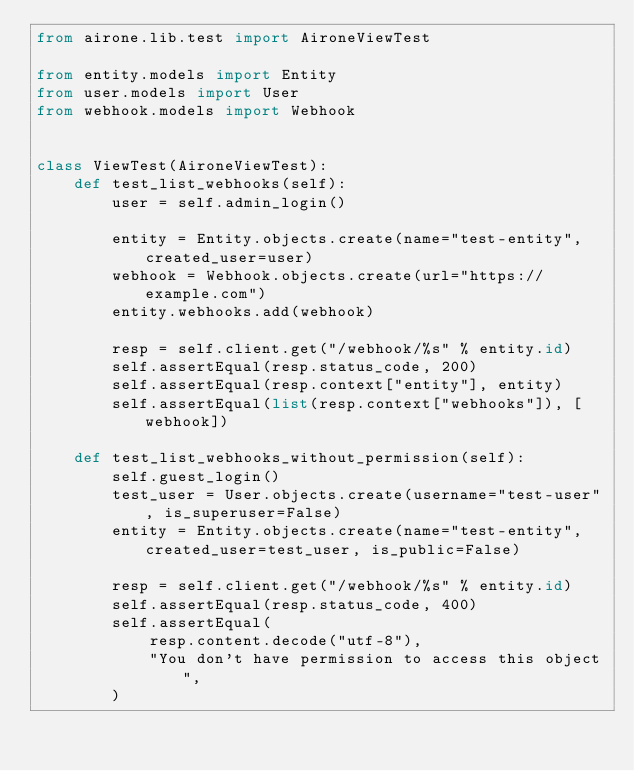Convert code to text. <code><loc_0><loc_0><loc_500><loc_500><_Python_>from airone.lib.test import AironeViewTest

from entity.models import Entity
from user.models import User
from webhook.models import Webhook


class ViewTest(AironeViewTest):
    def test_list_webhooks(self):
        user = self.admin_login()

        entity = Entity.objects.create(name="test-entity", created_user=user)
        webhook = Webhook.objects.create(url="https://example.com")
        entity.webhooks.add(webhook)

        resp = self.client.get("/webhook/%s" % entity.id)
        self.assertEqual(resp.status_code, 200)
        self.assertEqual(resp.context["entity"], entity)
        self.assertEqual(list(resp.context["webhooks"]), [webhook])

    def test_list_webhooks_without_permission(self):
        self.guest_login()
        test_user = User.objects.create(username="test-user", is_superuser=False)
        entity = Entity.objects.create(name="test-entity", created_user=test_user, is_public=False)

        resp = self.client.get("/webhook/%s" % entity.id)
        self.assertEqual(resp.status_code, 400)
        self.assertEqual(
            resp.content.decode("utf-8"),
            "You don't have permission to access this object",
        )
</code> 